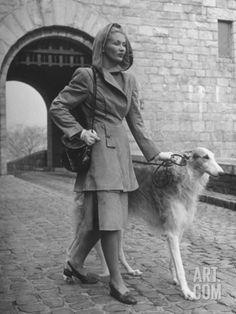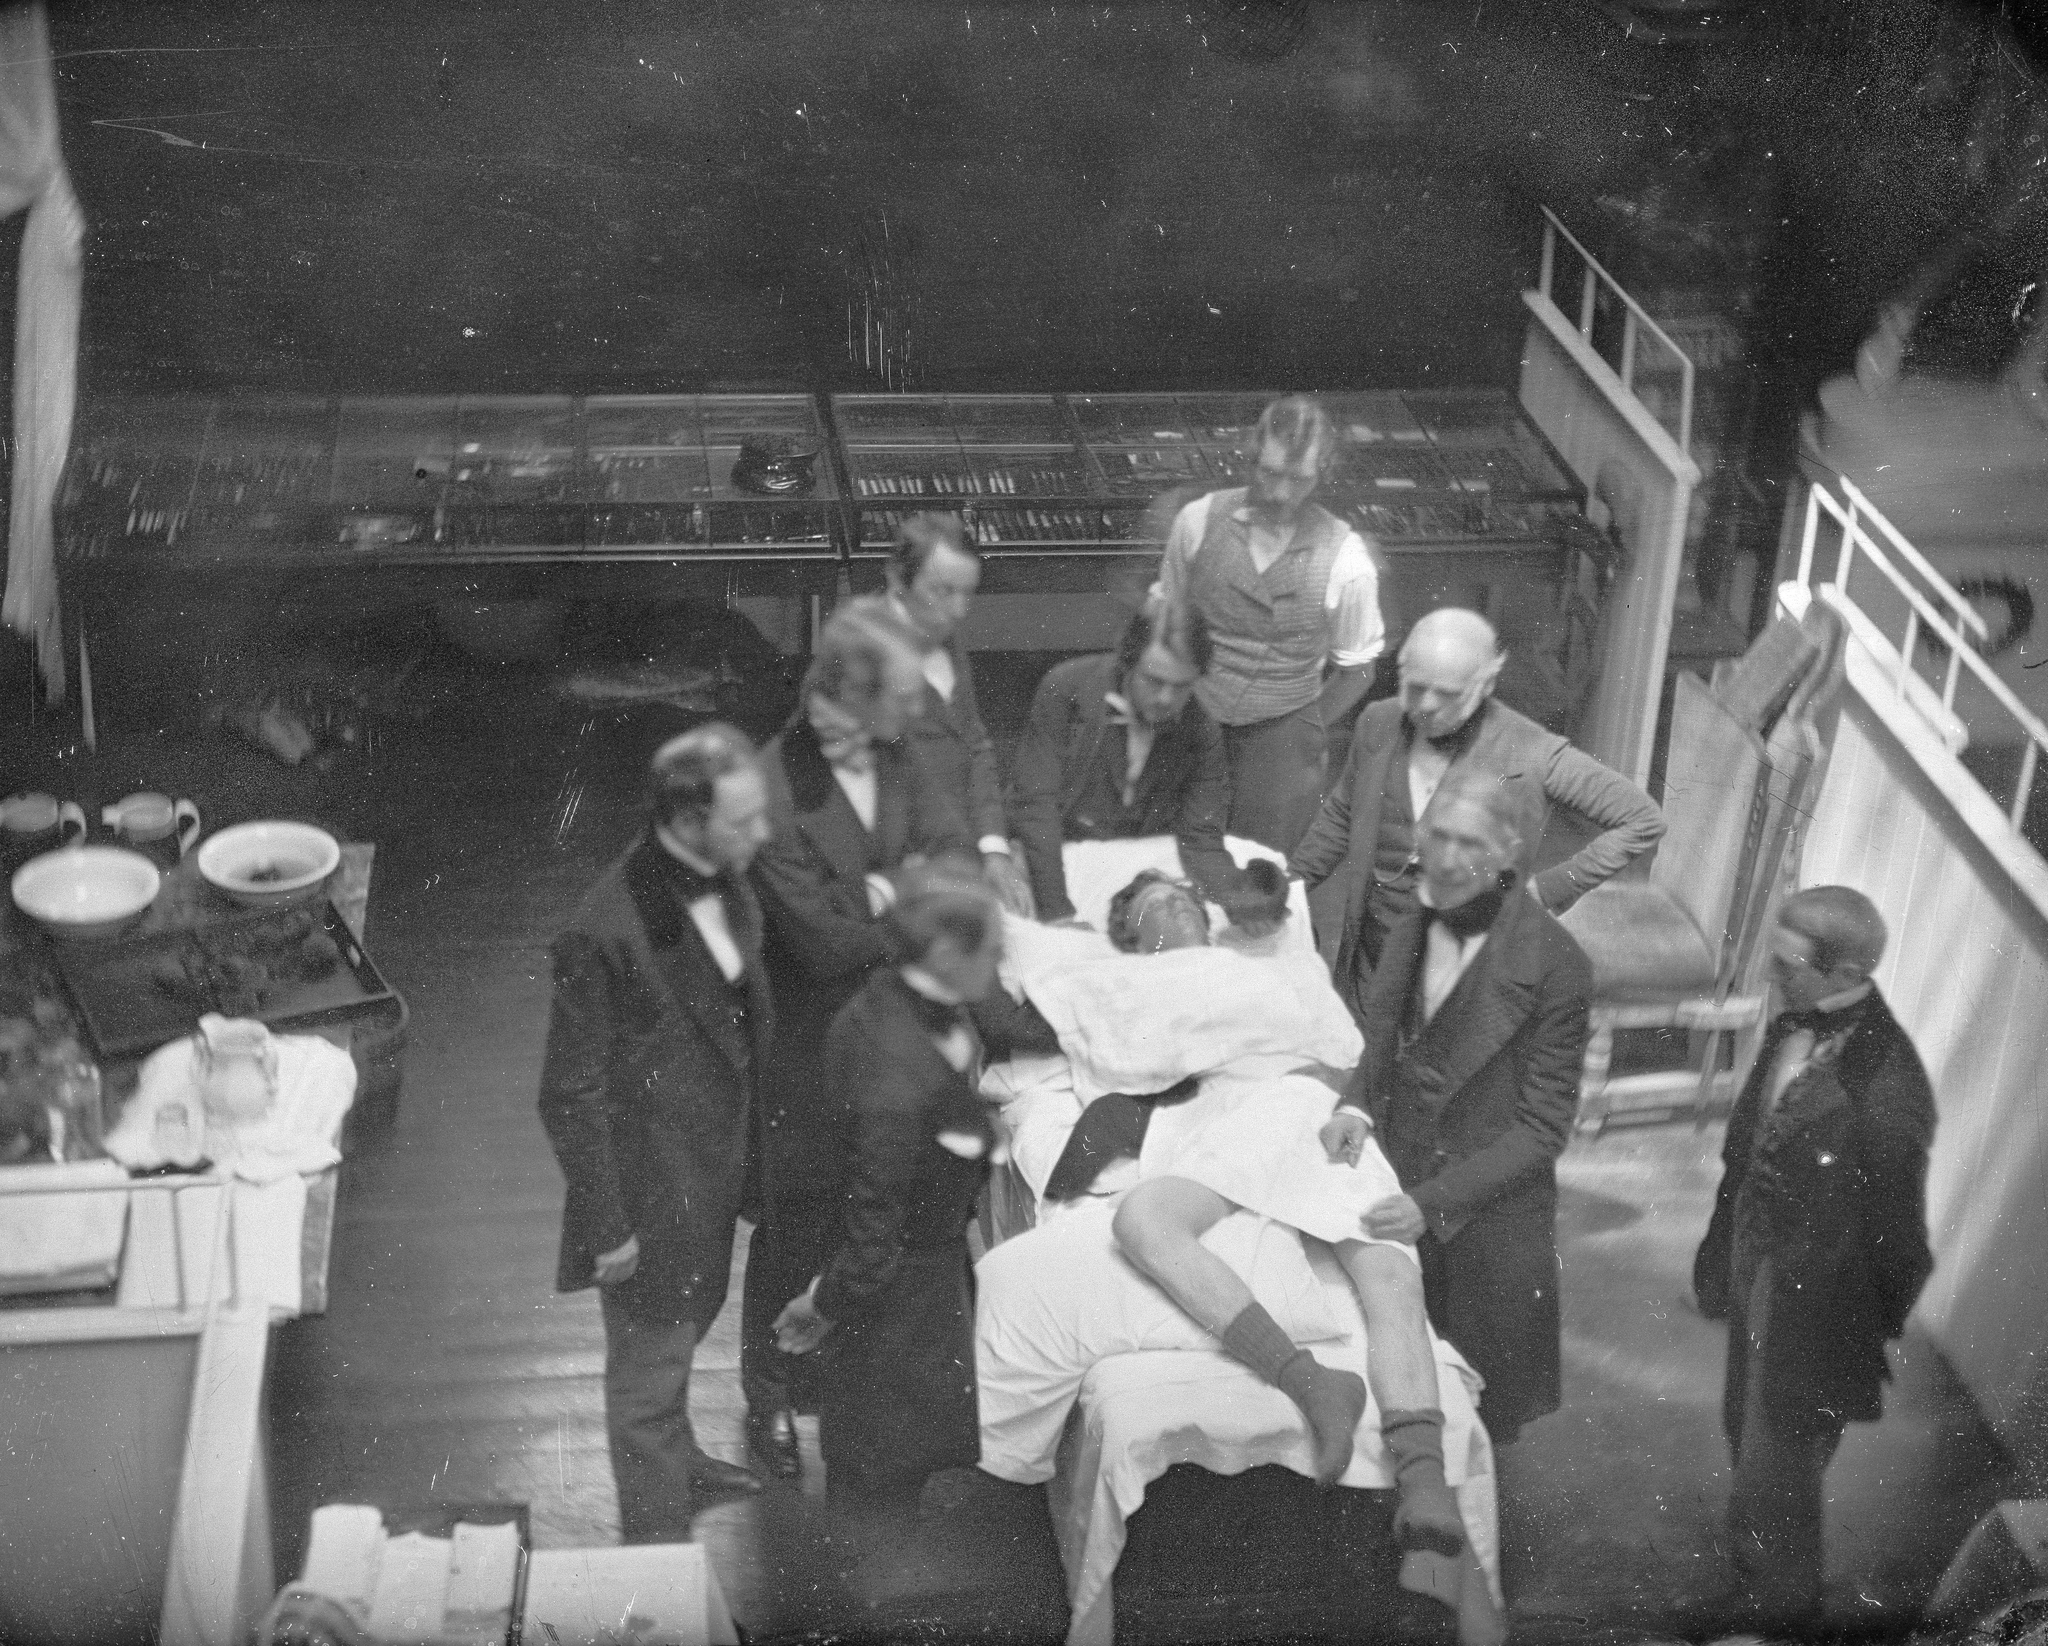The first image is the image on the left, the second image is the image on the right. For the images shown, is this caption "A vintage image shows a woman in a non-floor-length skirt, jacket and hat standing outdoors next to one afghan hound." true? Answer yes or no. Yes. The first image is the image on the left, the second image is the image on the right. Examine the images to the left and right. Is the description "A woman is standing with a single dog in the image on the right." accurate? Answer yes or no. No. 